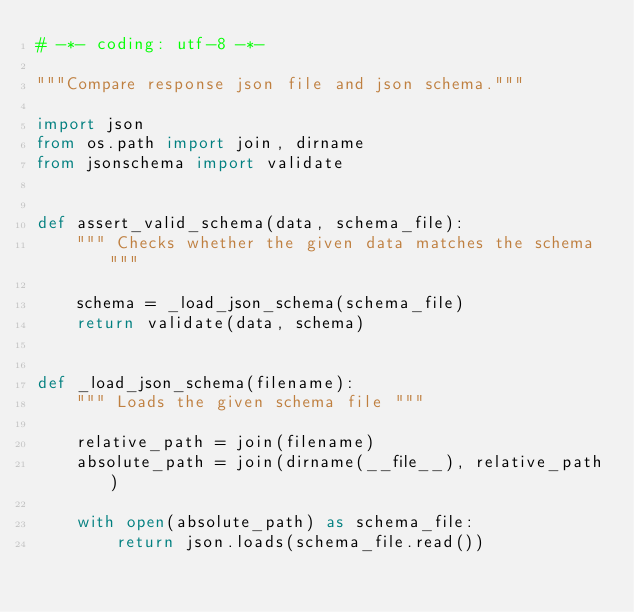Convert code to text. <code><loc_0><loc_0><loc_500><loc_500><_Python_># -*- coding: utf-8 -*-

"""Compare response json file and json schema."""

import json
from os.path import join, dirname
from jsonschema import validate


def assert_valid_schema(data, schema_file):
    """ Checks whether the given data matches the schema """

    schema = _load_json_schema(schema_file)
    return validate(data, schema)


def _load_json_schema(filename):
    """ Loads the given schema file """

    relative_path = join(filename)
    absolute_path = join(dirname(__file__), relative_path)

    with open(absolute_path) as schema_file:
        return json.loads(schema_file.read())
</code> 